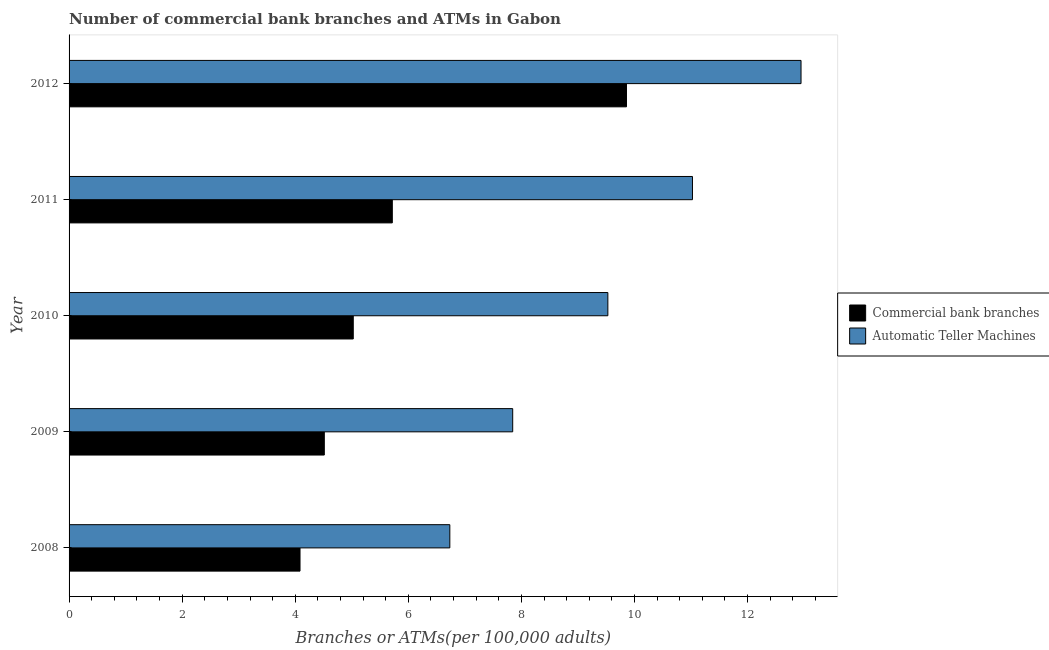How many groups of bars are there?
Your answer should be compact. 5. Are the number of bars per tick equal to the number of legend labels?
Keep it short and to the point. Yes. How many bars are there on the 4th tick from the top?
Keep it short and to the point. 2. What is the number of atms in 2009?
Provide a succinct answer. 7.85. Across all years, what is the maximum number of atms?
Give a very brief answer. 12.95. Across all years, what is the minimum number of atms?
Offer a very short reply. 6.73. In which year was the number of atms maximum?
Offer a very short reply. 2012. In which year was the number of commercal bank branches minimum?
Your answer should be very brief. 2008. What is the total number of atms in the graph?
Ensure brevity in your answer.  48.08. What is the difference between the number of atms in 2010 and that in 2012?
Your response must be concise. -3.42. What is the difference between the number of atms in 2010 and the number of commercal bank branches in 2009?
Give a very brief answer. 5.01. What is the average number of commercal bank branches per year?
Your answer should be compact. 5.84. In the year 2011, what is the difference between the number of commercal bank branches and number of atms?
Ensure brevity in your answer.  -5.31. In how many years, is the number of commercal bank branches greater than 11.6 ?
Provide a short and direct response. 0. What is the ratio of the number of commercal bank branches in 2008 to that in 2012?
Your response must be concise. 0.41. Is the number of commercal bank branches in 2009 less than that in 2012?
Keep it short and to the point. Yes. What is the difference between the highest and the second highest number of commercal bank branches?
Offer a terse response. 4.14. What is the difference between the highest and the lowest number of commercal bank branches?
Offer a terse response. 5.77. In how many years, is the number of atms greater than the average number of atms taken over all years?
Make the answer very short. 2. What does the 1st bar from the top in 2008 represents?
Provide a short and direct response. Automatic Teller Machines. What does the 2nd bar from the bottom in 2009 represents?
Offer a terse response. Automatic Teller Machines. How many bars are there?
Offer a very short reply. 10. Are all the bars in the graph horizontal?
Provide a short and direct response. Yes. How many years are there in the graph?
Give a very brief answer. 5. Does the graph contain any zero values?
Your answer should be very brief. No. Does the graph contain grids?
Offer a terse response. No. Where does the legend appear in the graph?
Ensure brevity in your answer.  Center right. How are the legend labels stacked?
Your response must be concise. Vertical. What is the title of the graph?
Give a very brief answer. Number of commercial bank branches and ATMs in Gabon. Does "Broad money growth" appear as one of the legend labels in the graph?
Your answer should be compact. No. What is the label or title of the X-axis?
Your response must be concise. Branches or ATMs(per 100,0 adults). What is the Branches or ATMs(per 100,000 adults) of Commercial bank branches in 2008?
Ensure brevity in your answer.  4.08. What is the Branches or ATMs(per 100,000 adults) of Automatic Teller Machines in 2008?
Keep it short and to the point. 6.73. What is the Branches or ATMs(per 100,000 adults) in Commercial bank branches in 2009?
Your response must be concise. 4.51. What is the Branches or ATMs(per 100,000 adults) of Automatic Teller Machines in 2009?
Provide a short and direct response. 7.85. What is the Branches or ATMs(per 100,000 adults) of Commercial bank branches in 2010?
Your answer should be compact. 5.03. What is the Branches or ATMs(per 100,000 adults) of Automatic Teller Machines in 2010?
Keep it short and to the point. 9.53. What is the Branches or ATMs(per 100,000 adults) of Commercial bank branches in 2011?
Your answer should be very brief. 5.72. What is the Branches or ATMs(per 100,000 adults) in Automatic Teller Machines in 2011?
Give a very brief answer. 11.03. What is the Branches or ATMs(per 100,000 adults) in Commercial bank branches in 2012?
Your answer should be compact. 9.86. What is the Branches or ATMs(per 100,000 adults) of Automatic Teller Machines in 2012?
Your answer should be very brief. 12.95. Across all years, what is the maximum Branches or ATMs(per 100,000 adults) in Commercial bank branches?
Your response must be concise. 9.86. Across all years, what is the maximum Branches or ATMs(per 100,000 adults) in Automatic Teller Machines?
Ensure brevity in your answer.  12.95. Across all years, what is the minimum Branches or ATMs(per 100,000 adults) in Commercial bank branches?
Provide a succinct answer. 4.08. Across all years, what is the minimum Branches or ATMs(per 100,000 adults) in Automatic Teller Machines?
Provide a succinct answer. 6.73. What is the total Branches or ATMs(per 100,000 adults) of Commercial bank branches in the graph?
Give a very brief answer. 29.2. What is the total Branches or ATMs(per 100,000 adults) of Automatic Teller Machines in the graph?
Offer a terse response. 48.08. What is the difference between the Branches or ATMs(per 100,000 adults) of Commercial bank branches in 2008 and that in 2009?
Make the answer very short. -0.43. What is the difference between the Branches or ATMs(per 100,000 adults) of Automatic Teller Machines in 2008 and that in 2009?
Offer a terse response. -1.11. What is the difference between the Branches or ATMs(per 100,000 adults) of Commercial bank branches in 2008 and that in 2010?
Ensure brevity in your answer.  -0.94. What is the difference between the Branches or ATMs(per 100,000 adults) of Automatic Teller Machines in 2008 and that in 2010?
Ensure brevity in your answer.  -2.79. What is the difference between the Branches or ATMs(per 100,000 adults) of Commercial bank branches in 2008 and that in 2011?
Provide a succinct answer. -1.63. What is the difference between the Branches or ATMs(per 100,000 adults) in Automatic Teller Machines in 2008 and that in 2011?
Your answer should be compact. -4.29. What is the difference between the Branches or ATMs(per 100,000 adults) in Commercial bank branches in 2008 and that in 2012?
Ensure brevity in your answer.  -5.77. What is the difference between the Branches or ATMs(per 100,000 adults) of Automatic Teller Machines in 2008 and that in 2012?
Keep it short and to the point. -6.21. What is the difference between the Branches or ATMs(per 100,000 adults) in Commercial bank branches in 2009 and that in 2010?
Your answer should be very brief. -0.51. What is the difference between the Branches or ATMs(per 100,000 adults) of Automatic Teller Machines in 2009 and that in 2010?
Provide a succinct answer. -1.68. What is the difference between the Branches or ATMs(per 100,000 adults) of Commercial bank branches in 2009 and that in 2011?
Your answer should be very brief. -1.2. What is the difference between the Branches or ATMs(per 100,000 adults) of Automatic Teller Machines in 2009 and that in 2011?
Offer a very short reply. -3.18. What is the difference between the Branches or ATMs(per 100,000 adults) of Commercial bank branches in 2009 and that in 2012?
Provide a short and direct response. -5.34. What is the difference between the Branches or ATMs(per 100,000 adults) of Automatic Teller Machines in 2009 and that in 2012?
Ensure brevity in your answer.  -5.1. What is the difference between the Branches or ATMs(per 100,000 adults) of Commercial bank branches in 2010 and that in 2011?
Make the answer very short. -0.69. What is the difference between the Branches or ATMs(per 100,000 adults) of Automatic Teller Machines in 2010 and that in 2011?
Provide a succinct answer. -1.5. What is the difference between the Branches or ATMs(per 100,000 adults) of Commercial bank branches in 2010 and that in 2012?
Provide a succinct answer. -4.83. What is the difference between the Branches or ATMs(per 100,000 adults) in Automatic Teller Machines in 2010 and that in 2012?
Your answer should be very brief. -3.42. What is the difference between the Branches or ATMs(per 100,000 adults) in Commercial bank branches in 2011 and that in 2012?
Offer a terse response. -4.14. What is the difference between the Branches or ATMs(per 100,000 adults) in Automatic Teller Machines in 2011 and that in 2012?
Offer a terse response. -1.92. What is the difference between the Branches or ATMs(per 100,000 adults) of Commercial bank branches in 2008 and the Branches or ATMs(per 100,000 adults) of Automatic Teller Machines in 2009?
Your response must be concise. -3.76. What is the difference between the Branches or ATMs(per 100,000 adults) in Commercial bank branches in 2008 and the Branches or ATMs(per 100,000 adults) in Automatic Teller Machines in 2010?
Your answer should be very brief. -5.44. What is the difference between the Branches or ATMs(per 100,000 adults) of Commercial bank branches in 2008 and the Branches or ATMs(per 100,000 adults) of Automatic Teller Machines in 2011?
Keep it short and to the point. -6.94. What is the difference between the Branches or ATMs(per 100,000 adults) of Commercial bank branches in 2008 and the Branches or ATMs(per 100,000 adults) of Automatic Teller Machines in 2012?
Offer a very short reply. -8.86. What is the difference between the Branches or ATMs(per 100,000 adults) in Commercial bank branches in 2009 and the Branches or ATMs(per 100,000 adults) in Automatic Teller Machines in 2010?
Offer a terse response. -5.01. What is the difference between the Branches or ATMs(per 100,000 adults) in Commercial bank branches in 2009 and the Branches or ATMs(per 100,000 adults) in Automatic Teller Machines in 2011?
Offer a very short reply. -6.51. What is the difference between the Branches or ATMs(per 100,000 adults) of Commercial bank branches in 2009 and the Branches or ATMs(per 100,000 adults) of Automatic Teller Machines in 2012?
Your answer should be compact. -8.43. What is the difference between the Branches or ATMs(per 100,000 adults) of Commercial bank branches in 2010 and the Branches or ATMs(per 100,000 adults) of Automatic Teller Machines in 2011?
Keep it short and to the point. -6. What is the difference between the Branches or ATMs(per 100,000 adults) in Commercial bank branches in 2010 and the Branches or ATMs(per 100,000 adults) in Automatic Teller Machines in 2012?
Make the answer very short. -7.92. What is the difference between the Branches or ATMs(per 100,000 adults) of Commercial bank branches in 2011 and the Branches or ATMs(per 100,000 adults) of Automatic Teller Machines in 2012?
Provide a succinct answer. -7.23. What is the average Branches or ATMs(per 100,000 adults) of Commercial bank branches per year?
Provide a short and direct response. 5.84. What is the average Branches or ATMs(per 100,000 adults) in Automatic Teller Machines per year?
Offer a terse response. 9.62. In the year 2008, what is the difference between the Branches or ATMs(per 100,000 adults) in Commercial bank branches and Branches or ATMs(per 100,000 adults) in Automatic Teller Machines?
Your answer should be compact. -2.65. In the year 2009, what is the difference between the Branches or ATMs(per 100,000 adults) of Commercial bank branches and Branches or ATMs(per 100,000 adults) of Automatic Teller Machines?
Keep it short and to the point. -3.33. In the year 2010, what is the difference between the Branches or ATMs(per 100,000 adults) in Commercial bank branches and Branches or ATMs(per 100,000 adults) in Automatic Teller Machines?
Ensure brevity in your answer.  -4.5. In the year 2011, what is the difference between the Branches or ATMs(per 100,000 adults) in Commercial bank branches and Branches or ATMs(per 100,000 adults) in Automatic Teller Machines?
Make the answer very short. -5.31. In the year 2012, what is the difference between the Branches or ATMs(per 100,000 adults) of Commercial bank branches and Branches or ATMs(per 100,000 adults) of Automatic Teller Machines?
Offer a very short reply. -3.09. What is the ratio of the Branches or ATMs(per 100,000 adults) in Commercial bank branches in 2008 to that in 2009?
Offer a terse response. 0.9. What is the ratio of the Branches or ATMs(per 100,000 adults) of Automatic Teller Machines in 2008 to that in 2009?
Give a very brief answer. 0.86. What is the ratio of the Branches or ATMs(per 100,000 adults) of Commercial bank branches in 2008 to that in 2010?
Your answer should be compact. 0.81. What is the ratio of the Branches or ATMs(per 100,000 adults) of Automatic Teller Machines in 2008 to that in 2010?
Offer a very short reply. 0.71. What is the ratio of the Branches or ATMs(per 100,000 adults) of Commercial bank branches in 2008 to that in 2011?
Make the answer very short. 0.71. What is the ratio of the Branches or ATMs(per 100,000 adults) of Automatic Teller Machines in 2008 to that in 2011?
Give a very brief answer. 0.61. What is the ratio of the Branches or ATMs(per 100,000 adults) of Commercial bank branches in 2008 to that in 2012?
Make the answer very short. 0.41. What is the ratio of the Branches or ATMs(per 100,000 adults) in Automatic Teller Machines in 2008 to that in 2012?
Keep it short and to the point. 0.52. What is the ratio of the Branches or ATMs(per 100,000 adults) of Commercial bank branches in 2009 to that in 2010?
Your answer should be compact. 0.9. What is the ratio of the Branches or ATMs(per 100,000 adults) of Automatic Teller Machines in 2009 to that in 2010?
Give a very brief answer. 0.82. What is the ratio of the Branches or ATMs(per 100,000 adults) of Commercial bank branches in 2009 to that in 2011?
Keep it short and to the point. 0.79. What is the ratio of the Branches or ATMs(per 100,000 adults) of Automatic Teller Machines in 2009 to that in 2011?
Make the answer very short. 0.71. What is the ratio of the Branches or ATMs(per 100,000 adults) in Commercial bank branches in 2009 to that in 2012?
Offer a terse response. 0.46. What is the ratio of the Branches or ATMs(per 100,000 adults) in Automatic Teller Machines in 2009 to that in 2012?
Your response must be concise. 0.61. What is the ratio of the Branches or ATMs(per 100,000 adults) in Commercial bank branches in 2010 to that in 2011?
Provide a succinct answer. 0.88. What is the ratio of the Branches or ATMs(per 100,000 adults) in Automatic Teller Machines in 2010 to that in 2011?
Keep it short and to the point. 0.86. What is the ratio of the Branches or ATMs(per 100,000 adults) of Commercial bank branches in 2010 to that in 2012?
Provide a short and direct response. 0.51. What is the ratio of the Branches or ATMs(per 100,000 adults) of Automatic Teller Machines in 2010 to that in 2012?
Keep it short and to the point. 0.74. What is the ratio of the Branches or ATMs(per 100,000 adults) in Commercial bank branches in 2011 to that in 2012?
Give a very brief answer. 0.58. What is the ratio of the Branches or ATMs(per 100,000 adults) in Automatic Teller Machines in 2011 to that in 2012?
Keep it short and to the point. 0.85. What is the difference between the highest and the second highest Branches or ATMs(per 100,000 adults) in Commercial bank branches?
Offer a very short reply. 4.14. What is the difference between the highest and the second highest Branches or ATMs(per 100,000 adults) in Automatic Teller Machines?
Give a very brief answer. 1.92. What is the difference between the highest and the lowest Branches or ATMs(per 100,000 adults) of Commercial bank branches?
Your response must be concise. 5.77. What is the difference between the highest and the lowest Branches or ATMs(per 100,000 adults) of Automatic Teller Machines?
Your answer should be very brief. 6.21. 